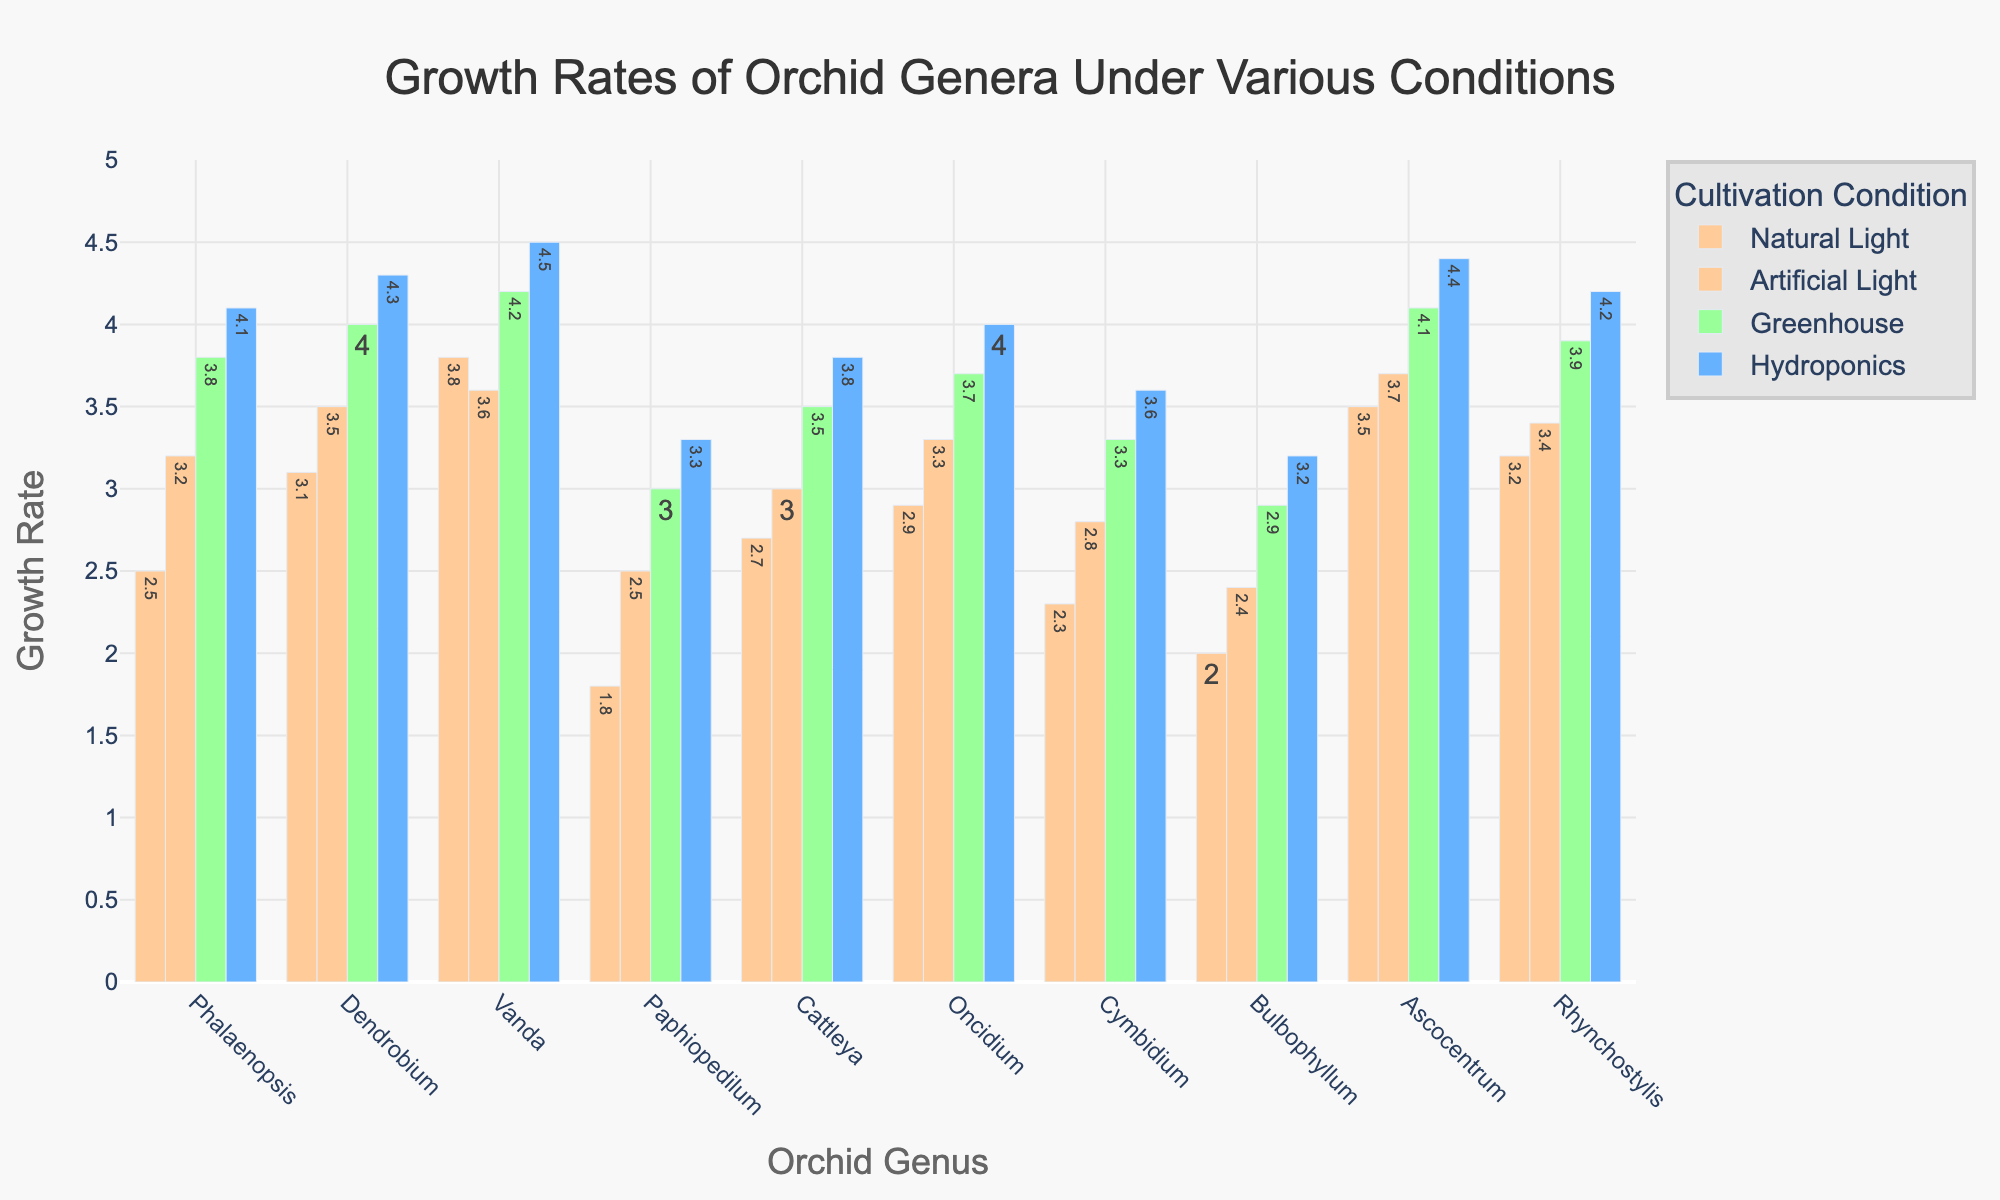What is the genus with the highest growth rate under Hydroponics? To determine this, compare the height of the bars labeled "Hydroponics" for each genus. The tallest bar corresponds to the genus with the highest growth rate.
Answer: Vanda Which genus has a higher growth rate under Artificial Light: Ascocentrum or Phalaenopsis? Compare the height of the bars labeled "Artificial Light" for Ascocentrum and Phalaenopsis. Ascocentrum's bar is higher than Phalaenopsis's bar.
Answer: Ascocentrum What is the difference in growth rates between Vanda under Natural Light and Vanda under Greenhouse conditions? To find this, subtract the growth rate of Vanda under Natural Light from its growth rate under Greenhouse conditions: 4.2 - 3.8.
Answer: 0.4 Which cultivation condition results in the highest growth rate for Rhynchostylis? Look at the bars corresponding to Rhynchostylis and identify the tallest bar. The tallest bar represents Hydroponics for Rhynchostylis.
Answer: Hydroponics What is the average growth rate of Dendrobium across all cultivation conditions? Add the growth rates of Dendrobium across all conditions and divide by the number of conditions: (3.1 + 3.5 + 4.0 + 4.3) / 4.
Answer: 3.725 How does the growth rate of Cattleya under Greenhouse conditions compare to that of Paphiopedilum under the same conditions? Compare the heights of the bars labeled "Greenhouse" for Cattleya and Paphiopedilum. Cattleya's bar is higher.
Answer: Higher For which genus is the growth rate under Natural Light the lowest? Look at the bars labeled "Natural Light" for each genus and find the shortest bar, which corresponds to Paphiopedilum.
Answer: Paphiopedilum What is the combined growth rate of Oncidium under Natural Light and Greenhouse conditions? Add the growth rates of Oncidium under Natural Light and Greenhouse conditions: 2.9 + 3.7.
Answer: 6.6 Which cultivation condition shows the smallest variation in growth rates across all genera? Compare the differences in bar heights for each condition (Natural Light, Artificial Light, Greenhouse, Hydroponics) and determine which condition has the most uniform bar heights.
Answer: Artificial Light 